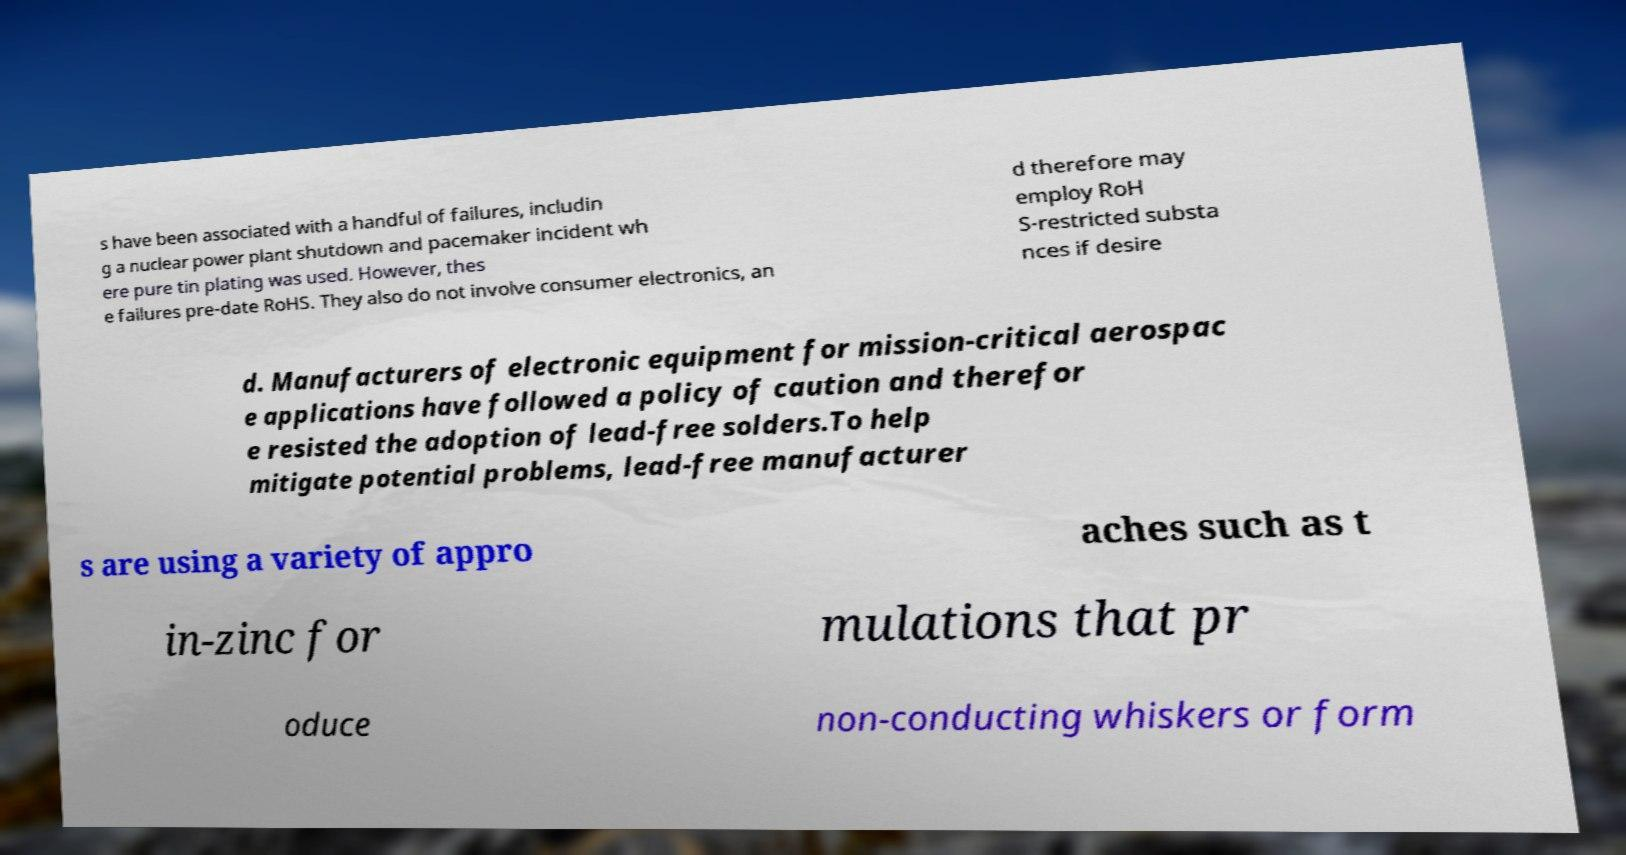For documentation purposes, I need the text within this image transcribed. Could you provide that? s have been associated with a handful of failures, includin g a nuclear power plant shutdown and pacemaker incident wh ere pure tin plating was used. However, thes e failures pre-date RoHS. They also do not involve consumer electronics, an d therefore may employ RoH S-restricted substa nces if desire d. Manufacturers of electronic equipment for mission-critical aerospac e applications have followed a policy of caution and therefor e resisted the adoption of lead-free solders.To help mitigate potential problems, lead-free manufacturer s are using a variety of appro aches such as t in-zinc for mulations that pr oduce non-conducting whiskers or form 